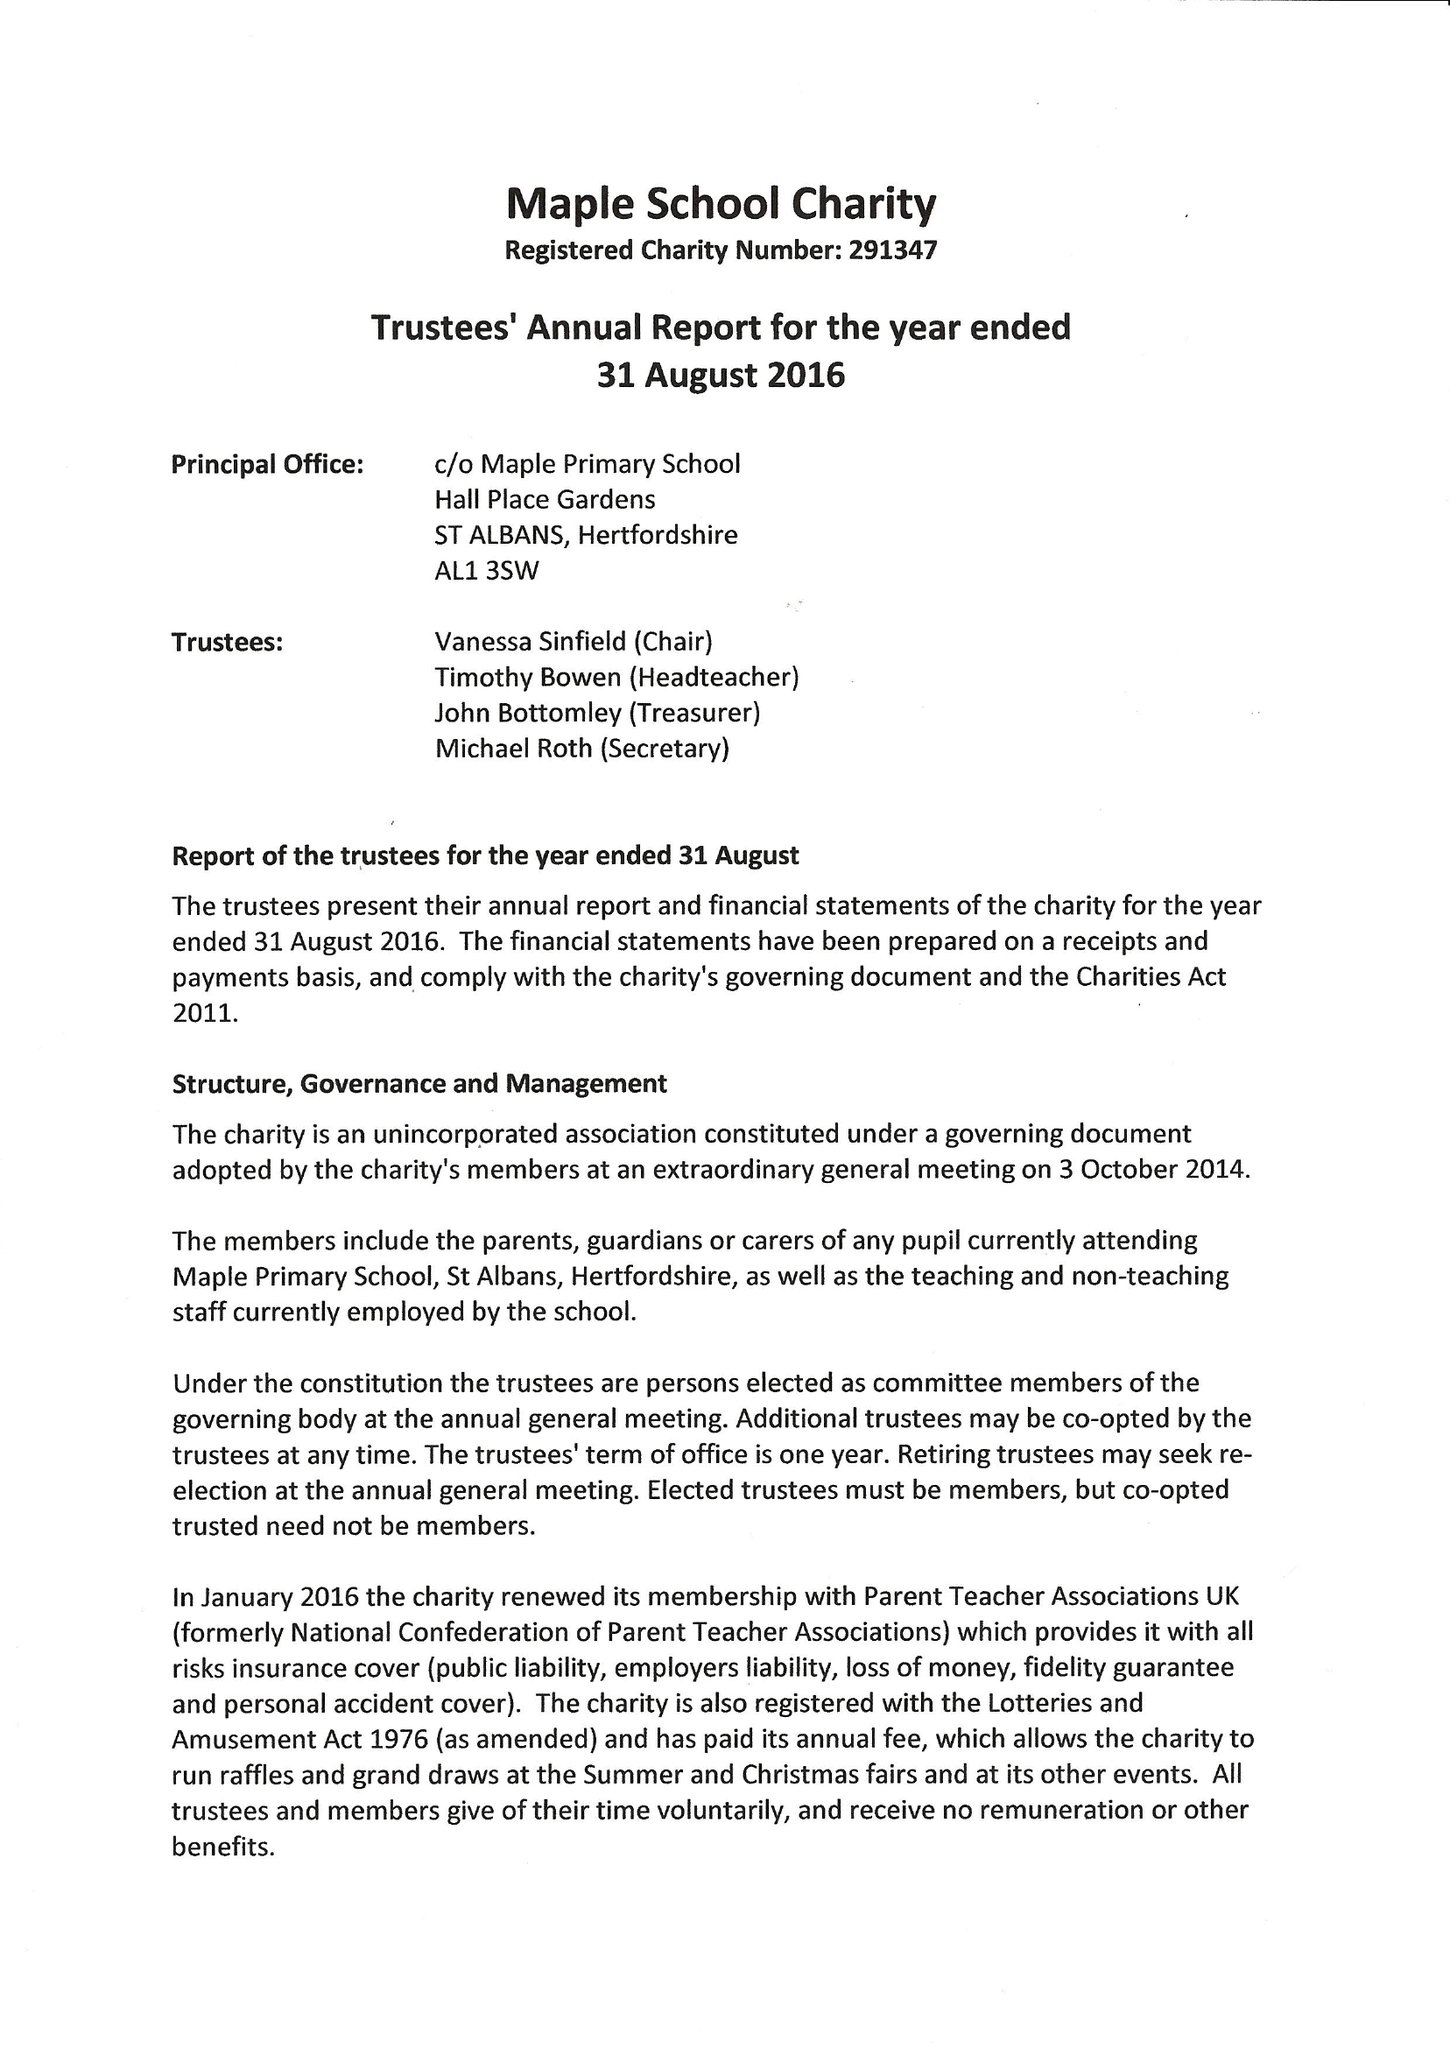What is the value for the address__post_town?
Answer the question using a single word or phrase. ST. ALBANS 